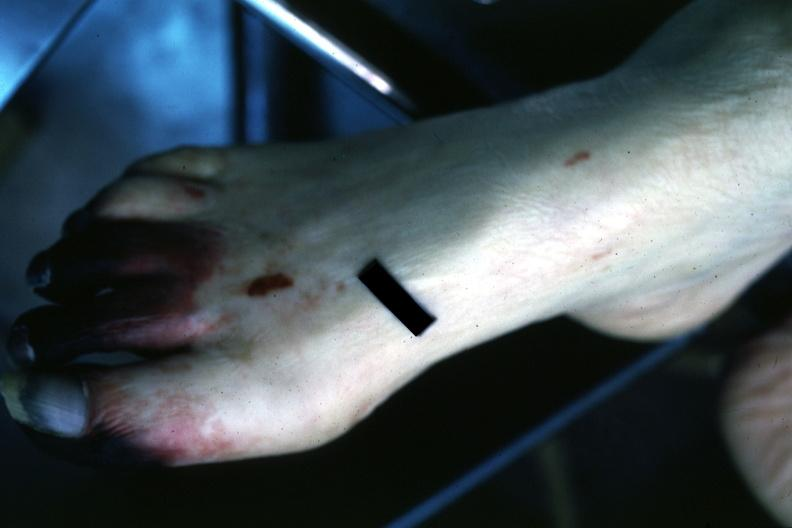does endocrine show well gangrenous 1-3 toes?
Answer the question using a single word or phrase. No 